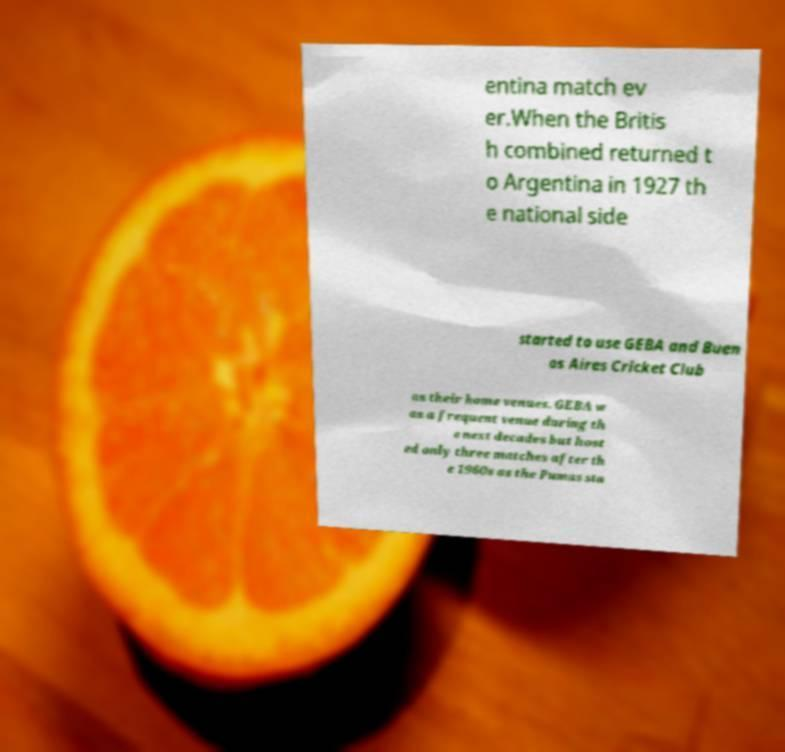Please identify and transcribe the text found in this image. entina match ev er.When the Britis h combined returned t o Argentina in 1927 th e national side started to use GEBA and Buen os Aires Cricket Club as their home venues. GEBA w as a frequent venue during th e next decades but host ed only three matches after th e 1960s as the Pumas sta 